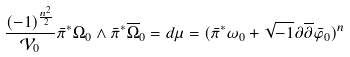Convert formula to latex. <formula><loc_0><loc_0><loc_500><loc_500>\frac { ( - 1 ) ^ { \frac { n ^ { 2 } } { 2 } } } { \mathcal { V } _ { 0 } } \bar { \pi } ^ { * } \Omega _ { 0 } \wedge \bar { \pi } ^ { * } \overline { \Omega } _ { 0 } = d \mu = ( \bar { \pi } ^ { * } \omega _ { 0 } + \sqrt { - 1 } \partial \overline { \partial } \bar { \varphi } _ { 0 } ) ^ { n }</formula> 